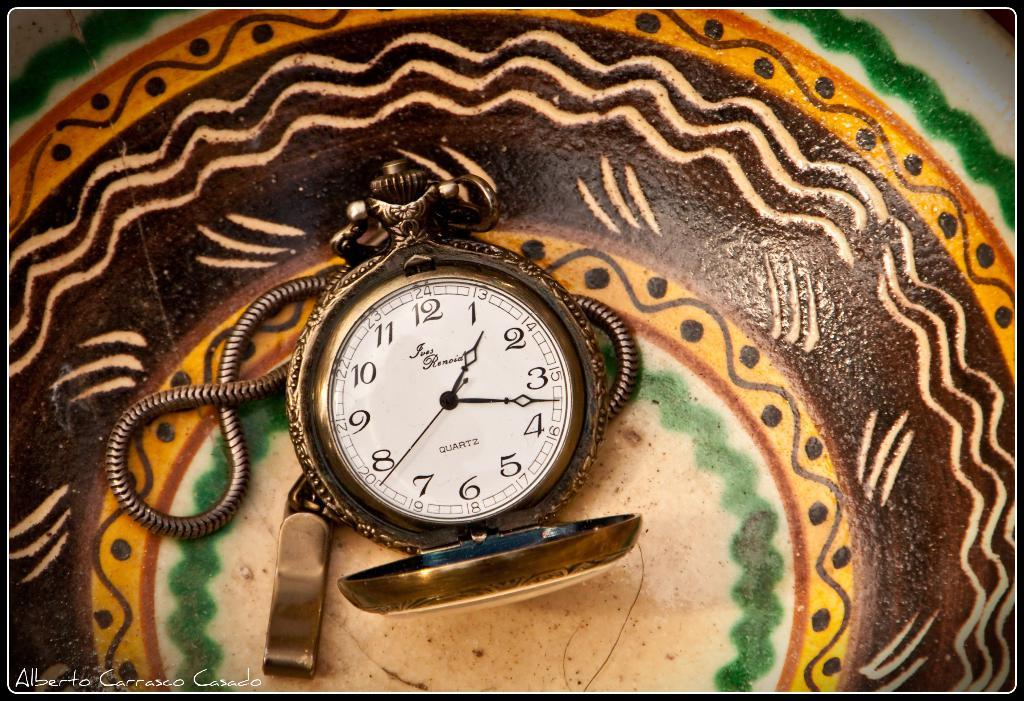<image>
Offer a succinct explanation of the picture presented. A photo of a stopwatch was taken by Alberto Carrasco Casado 